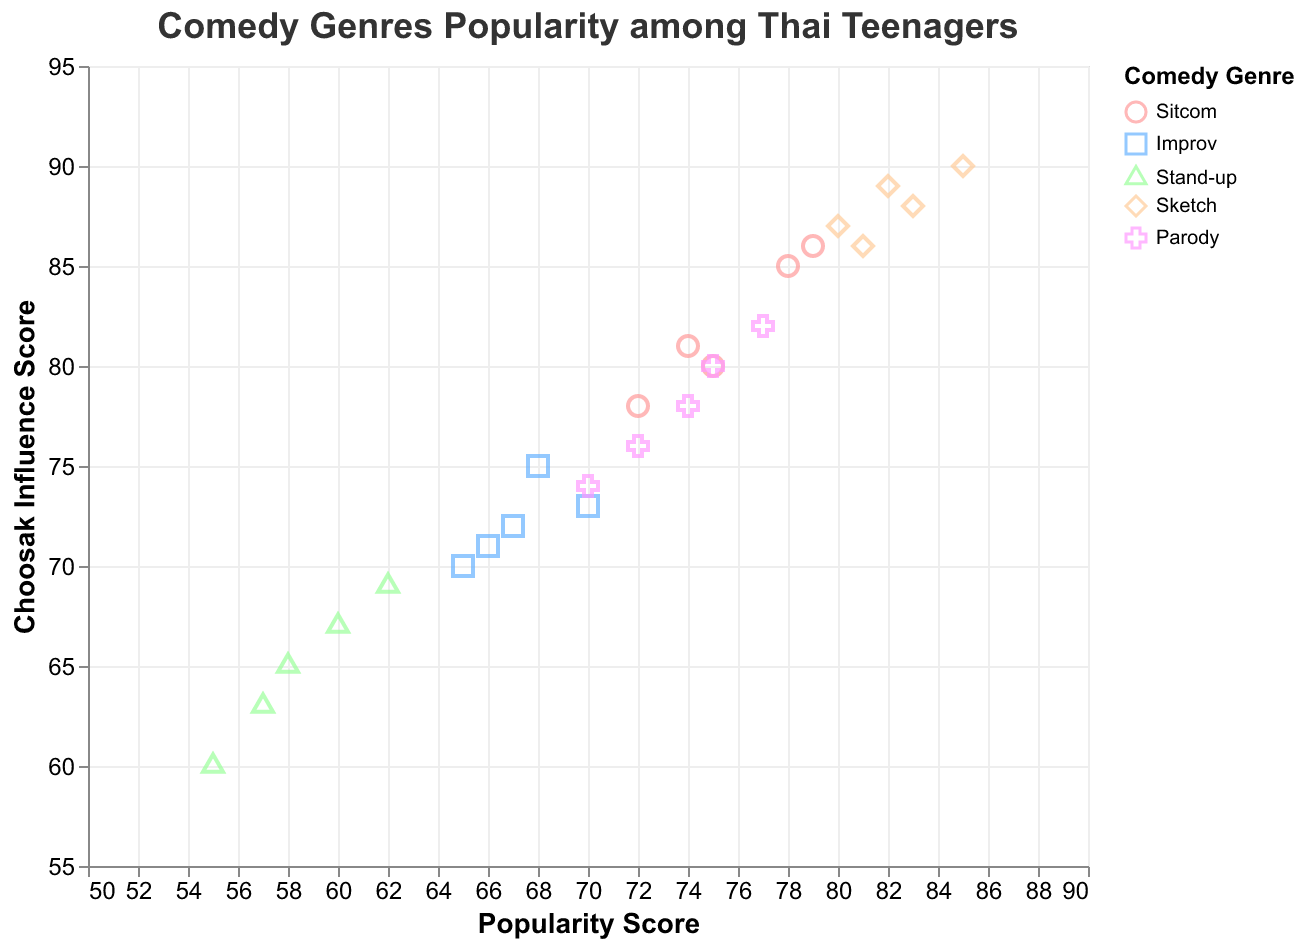What comedy genre has the highest popularity score on average? To find the genre with the highest average popularity score, calculate the average popularity score for each genre. Sitcom (75+72+78+74+79)/5 = 75.6, Improv (65+67+68+70+66)/5 = 67.2, Stand-up (55+57+58+60+62)/5 = 58.4, Sketch (80+82+85+83+81)/5 = 82.2, Parody (70+72+74+75+77)/5 = 73.6. Sketch has the highest average popularity score.
Answer: Sketch Which comedy genre shows the highest Choosak Influence Score across all ages? Look for the maximum value in the Choosak Influence Score column and the genre associated. The highest score is 90 for Sketch.
Answer: Sketch How does the popularity of Stand-up comedy change from age 13 to 17? Examine the Popularity_Score for Stand-up comedy for ages 13 through 17. The scores are 55, 57, 58, 60, and 62, respectively, showing an increasing trend.
Answer: It increases Which age group has the highest popularity score for Parody? Check the Popularity_Score for Parody across ages 13 to 17. The values are 70, 72, 74, 75, and 77. Age 17 has the highest popularity score for Parody.
Answer: 17 Among Thai teenagers aged 15, which comedy genre has the highest popularity score? Look at the Popularity_Score column for age 15. The genres and scores are Sitcom (78), Improv (68), Stand-up (58), Sketch (85), Parody (74). Sketch has the highest score at age 15.
Answer: Sketch What is the average Choosak Influence Score for Sketch comedy? Calculate the average of the Choosak Influence Score for Sketch. The values are 87, 89, 90, 88, and 86. The average is (87+89+90+88+86)/5 = 88.
Answer: 88 Is there a noticeable trend in Choosak Influence Score for Sitcom from age 13 to 17? Check the Choosak Influence Scores for Sitcom from age 13 to 17: 80, 78, 85, 81, 86. The scores fluctuate but generally increase.
Answer: Increasing Which age group shows the lowest popularity score for any genre, and what is that genre? Examine the Popularity_Score for all genres and ages. The lowest score is 55 for Stand-up at age 13.
Answer: Age 13, Stand-up Does the popularity of Improv comedy fluctuate or show a clear trend from age 13 to 17? The Popularity_Scores for Improv from age 13 to 17 are 65, 67, 68, 70, and 66. These values fluctuate with no clear increasing or decreasing trend.
Answer: Fluctuates 